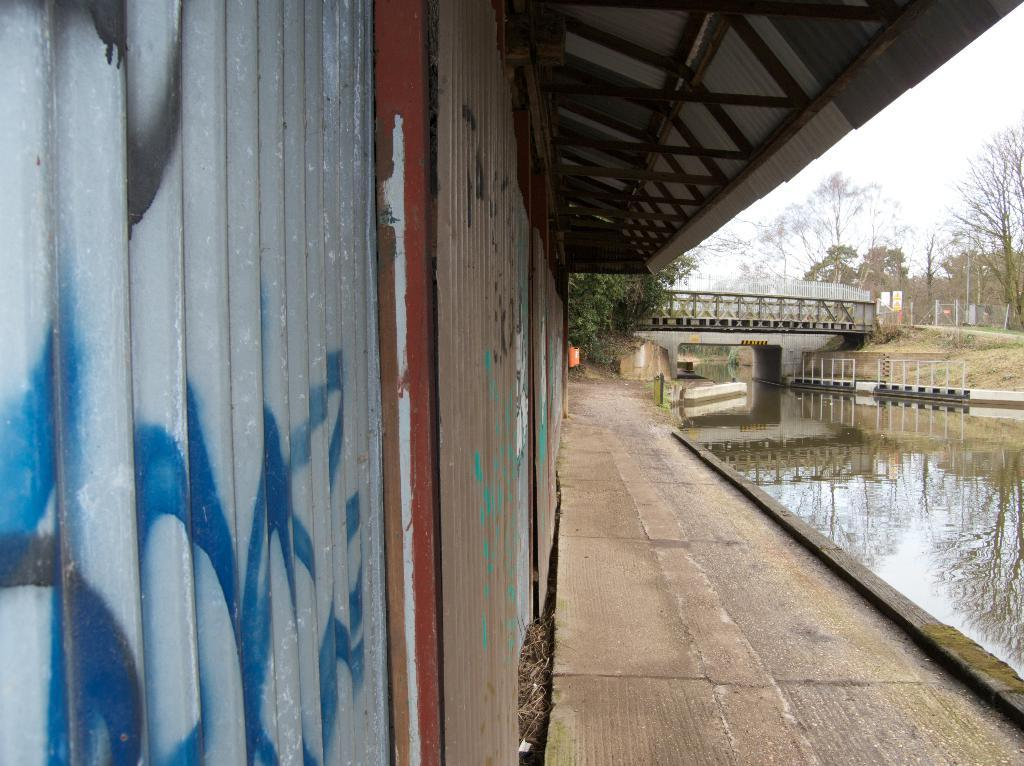What structure is located on the left side of the image? There is a house on the left side of the image. What type of natural feature is on the right side of the image? There is a sea on the right side of the image. What can be seen in the background of the image? There is a bridge and many trees in the background of the image. What is visible at the top of the image? The sky is visible at the top of the image. How does the house rub against the sea in the image? The house and the sea do not physically interact or rub against each other in the image; they are separate elements in the scene. 